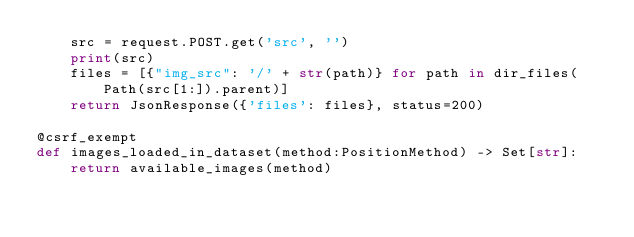<code> <loc_0><loc_0><loc_500><loc_500><_Python_>    src = request.POST.get('src', '')
    print(src)
    files = [{"img_src": '/' + str(path)} for path in dir_files(Path(src[1:]).parent)]
    return JsonResponse({'files': files}, status=200)

@csrf_exempt
def images_loaded_in_dataset(method:PositionMethod) -> Set[str]:
    return available_images(method)

</code> 